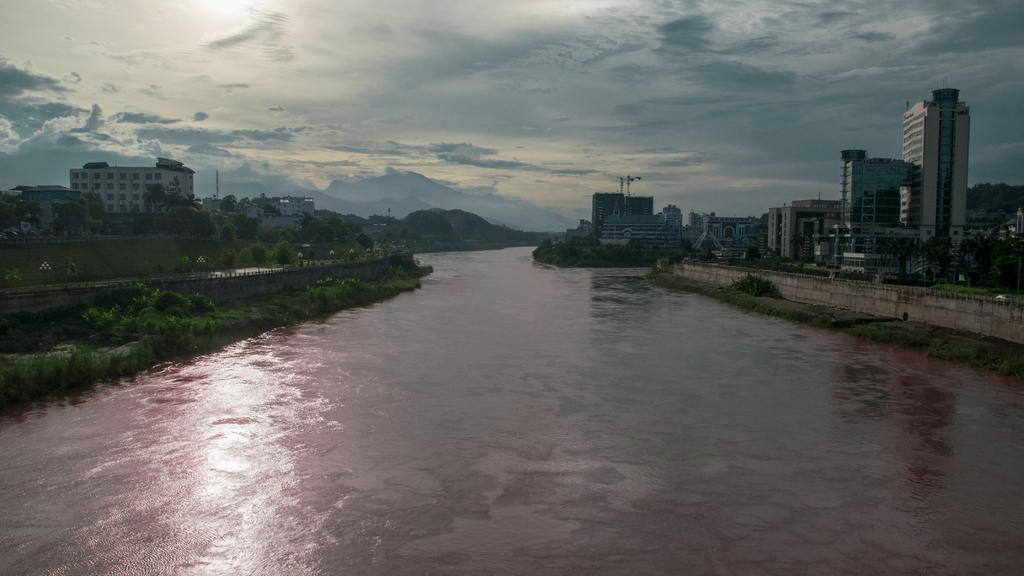What is the main feature of the image? There is a big river in the image. What can be seen near the river? There are buildings near the river. What type of vegetation is present in the image? There are plants in the image. What is the name of the goose swimming in the river in the image? There is no goose present in the image; it only features a big river, buildings, and plants. How many lizards can be seen basking on the riverbank in the image? There are no lizards present in the image. 